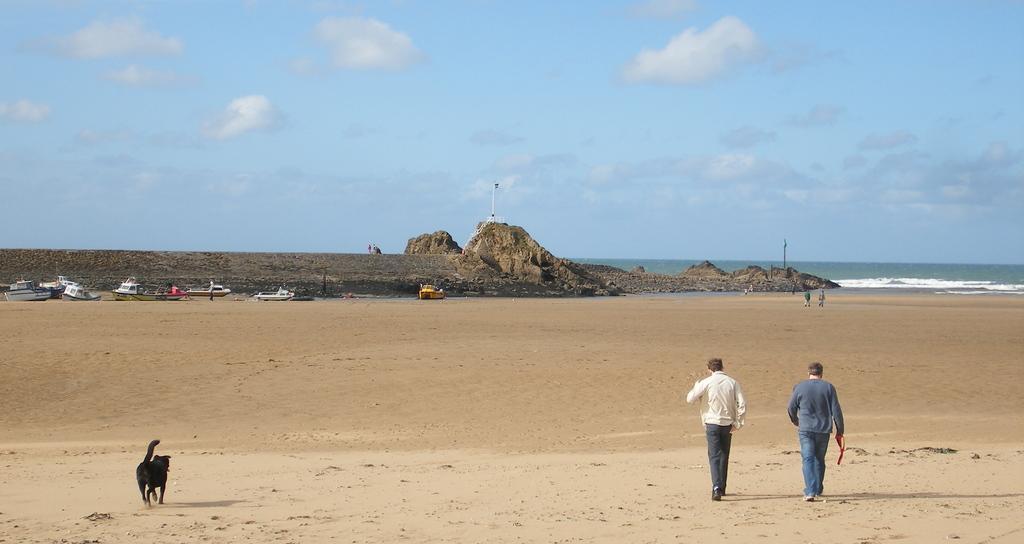Can you describe this image briefly? There is a dog and some people are walking on the sand. In the background there are boats, rock, water and sky with clouds. 